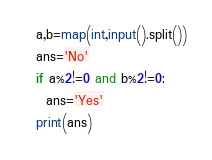<code> <loc_0><loc_0><loc_500><loc_500><_Python_>a,b=map(int,input().split())
ans='No'
if a%2!=0 and b%2!=0:
  ans='Yes'
print(ans)</code> 